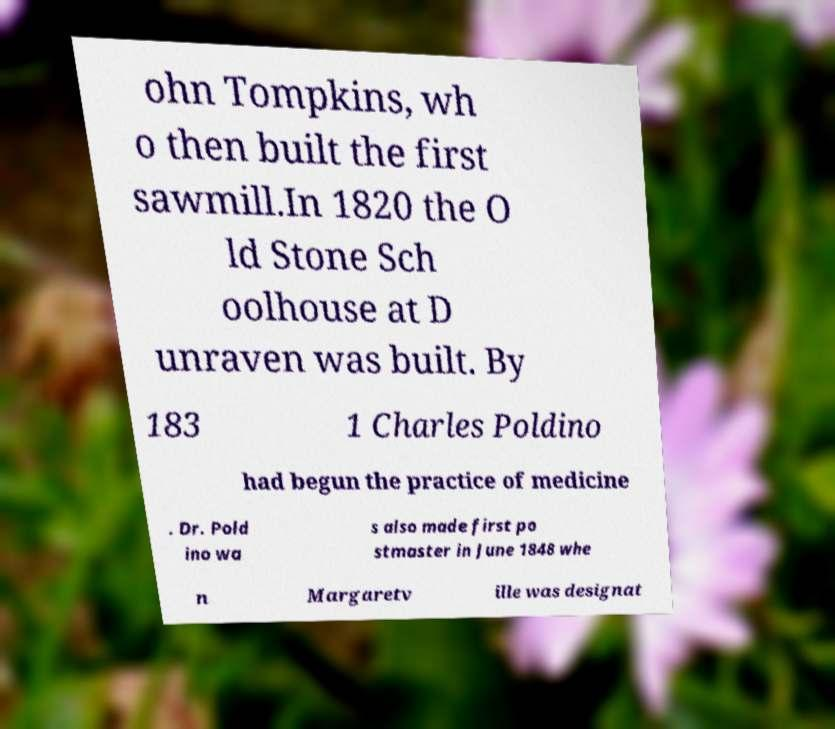For documentation purposes, I need the text within this image transcribed. Could you provide that? ohn Tompkins, wh o then built the first sawmill.In 1820 the O ld Stone Sch oolhouse at D unraven was built. By 183 1 Charles Poldino had begun the practice of medicine . Dr. Pold ino wa s also made first po stmaster in June 1848 whe n Margaretv ille was designat 